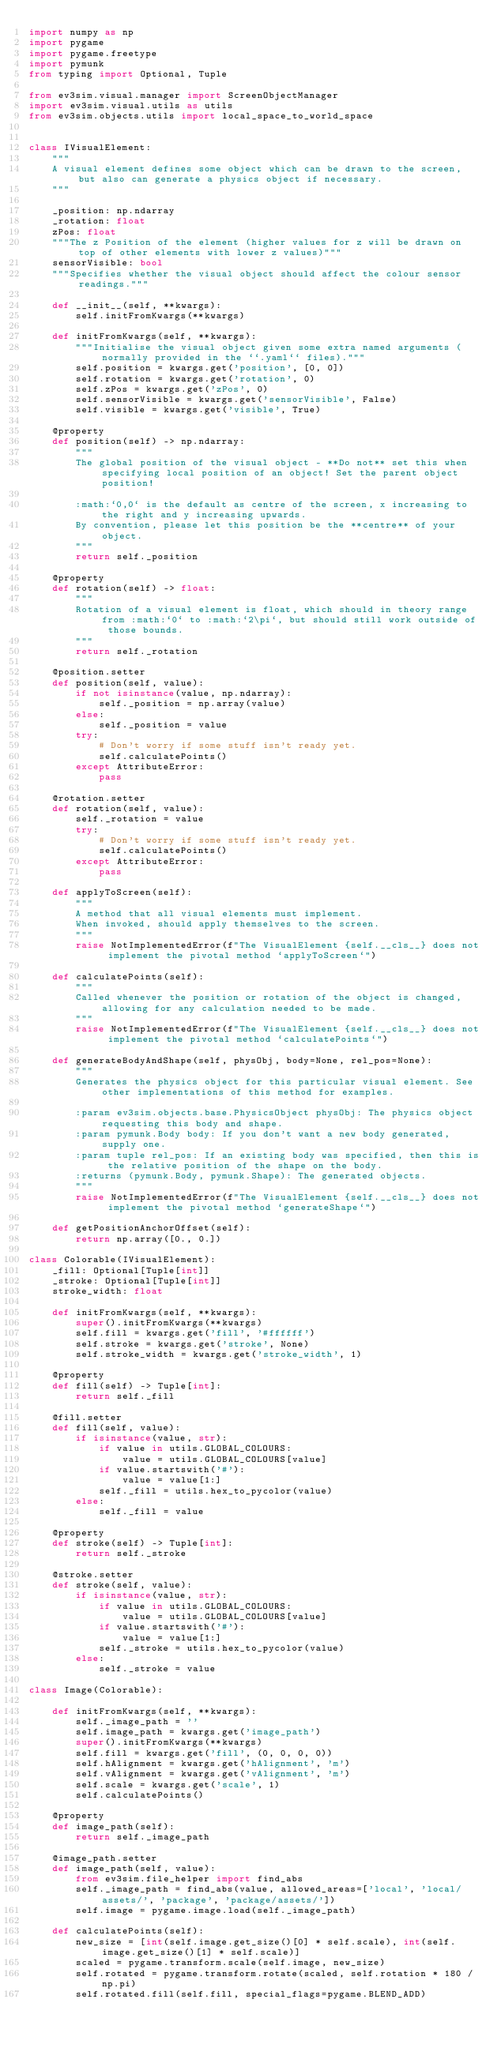<code> <loc_0><loc_0><loc_500><loc_500><_Python_>import numpy as np
import pygame
import pygame.freetype
import pymunk
from typing import Optional, Tuple

from ev3sim.visual.manager import ScreenObjectManager
import ev3sim.visual.utils as utils
from ev3sim.objects.utils import local_space_to_world_space


class IVisualElement:
    """
    A visual element defines some object which can be drawn to the screen, but also can generate a physics object if necessary.
    """

    _position: np.ndarray
    _rotation: float
    zPos: float
    """The z Position of the element (higher values for z will be drawn on top of other elements with lower z values)"""
    sensorVisible: bool
    """Specifies whether the visual object should affect the colour sensor readings."""

    def __init__(self, **kwargs):
        self.initFromKwargs(**kwargs)

    def initFromKwargs(self, **kwargs):
        """Initialise the visual object given some extra named arguments (normally provided in the ``.yaml`` files)."""
        self.position = kwargs.get('position', [0, 0])
        self.rotation = kwargs.get('rotation', 0)
        self.zPos = kwargs.get('zPos', 0)
        self.sensorVisible = kwargs.get('sensorVisible', False)
        self.visible = kwargs.get('visible', True)

    @property
    def position(self) -> np.ndarray:
        """
        The global position of the visual object - **Do not** set this when specifying local position of an object! Set the parent object position!
        
        :math:`0,0` is the default as centre of the screen, x increasing to the right and y increasing upwards.
        By convention, please let this position be the **centre** of your object.
        """
        return self._position

    @property
    def rotation(self) -> float:
        """
        Rotation of a visual element is float, which should in theory range from :math:`0` to :math:`2\pi`, but should still work outside of those bounds.
        """
        return self._rotation

    @position.setter
    def position(self, value):
        if not isinstance(value, np.ndarray):
            self._position = np.array(value)
        else:
            self._position = value
        try:
            # Don't worry if some stuff isn't ready yet.
            self.calculatePoints()
        except AttributeError:
            pass

    @rotation.setter
    def rotation(self, value):
        self._rotation = value
        try:
            # Don't worry if some stuff isn't ready yet.
            self.calculatePoints()
        except AttributeError:
            pass

    def applyToScreen(self):
        """
        A method that all visual elements must implement.
        When invoked, should apply themselves to the screen.
        """
        raise NotImplementedError(f"The VisualElement {self.__cls__} does not implement the pivotal method `applyToScreen`")

    def calculatePoints(self):
        """
        Called whenever the position or rotation of the object is changed, allowing for any calculation needed to be made.
        """
        raise NotImplementedError(f"The VisualElement {self.__cls__} does not implement the pivotal method `calculatePoints`")

    def generateBodyAndShape(self, physObj, body=None, rel_pos=None):
        """
        Generates the physics object for this particular visual element. See other implementations of this method for examples.

        :param ev3sim.objects.base.PhysicsObject physObj: The physics object requesting this body and shape.
        :param pymunk.Body body: If you don't want a new body generated, supply one.
        :param tuple rel_pos: If an existing body was specified, then this is the relative position of the shape on the body.
        :returns (pymunk.Body, pymunk.Shape): The generated objects.
        """
        raise NotImplementedError(f"The VisualElement {self.__cls__} does not implement the pivotal method `generateShape`")

    def getPositionAnchorOffset(self):
        return np.array([0., 0.])

class Colorable(IVisualElement):
    _fill: Optional[Tuple[int]]
    _stroke: Optional[Tuple[int]]
    stroke_width: float

    def initFromKwargs(self, **kwargs):
        super().initFromKwargs(**kwargs)
        self.fill = kwargs.get('fill', '#ffffff')
        self.stroke = kwargs.get('stroke', None)
        self.stroke_width = kwargs.get('stroke_width', 1)

    @property
    def fill(self) -> Tuple[int]:
        return self._fill

    @fill.setter
    def fill(self, value):
        if isinstance(value, str):
            if value in utils.GLOBAL_COLOURS:
                value = utils.GLOBAL_COLOURS[value]
            if value.startswith('#'):
                value = value[1:]
            self._fill = utils.hex_to_pycolor(value)
        else:
            self._fill = value

    @property
    def stroke(self) -> Tuple[int]:
        return self._stroke

    @stroke.setter
    def stroke(self, value):
        if isinstance(value, str):
            if value in utils.GLOBAL_COLOURS:
                value = utils.GLOBAL_COLOURS[value]
            if value.startswith('#'):
                value = value[1:]
            self._stroke = utils.hex_to_pycolor(value)
        else:
            self._stroke = value

class Image(Colorable):

    def initFromKwargs(self, **kwargs):
        self._image_path = ''
        self.image_path = kwargs.get('image_path')
        super().initFromKwargs(**kwargs)
        self.fill = kwargs.get('fill', (0, 0, 0, 0))
        self.hAlignment = kwargs.get('hAlignment', 'm')
        self.vAlignment = kwargs.get('vAlignment', 'm')
        self.scale = kwargs.get('scale', 1)
        self.calculatePoints()

    @property
    def image_path(self):
        return self._image_path

    @image_path.setter
    def image_path(self, value):
        from ev3sim.file_helper import find_abs
        self._image_path = find_abs(value, allowed_areas=['local', 'local/assets/', 'package', 'package/assets/'])
        self.image = pygame.image.load(self._image_path)

    def calculatePoints(self):
        new_size = [int(self.image.get_size()[0] * self.scale), int(self.image.get_size()[1] * self.scale)]
        scaled = pygame.transform.scale(self.image, new_size)
        self.rotated = pygame.transform.rotate(scaled, self.rotation * 180 / np.pi)
        self.rotated.fill(self.fill, special_flags=pygame.BLEND_ADD)</code> 